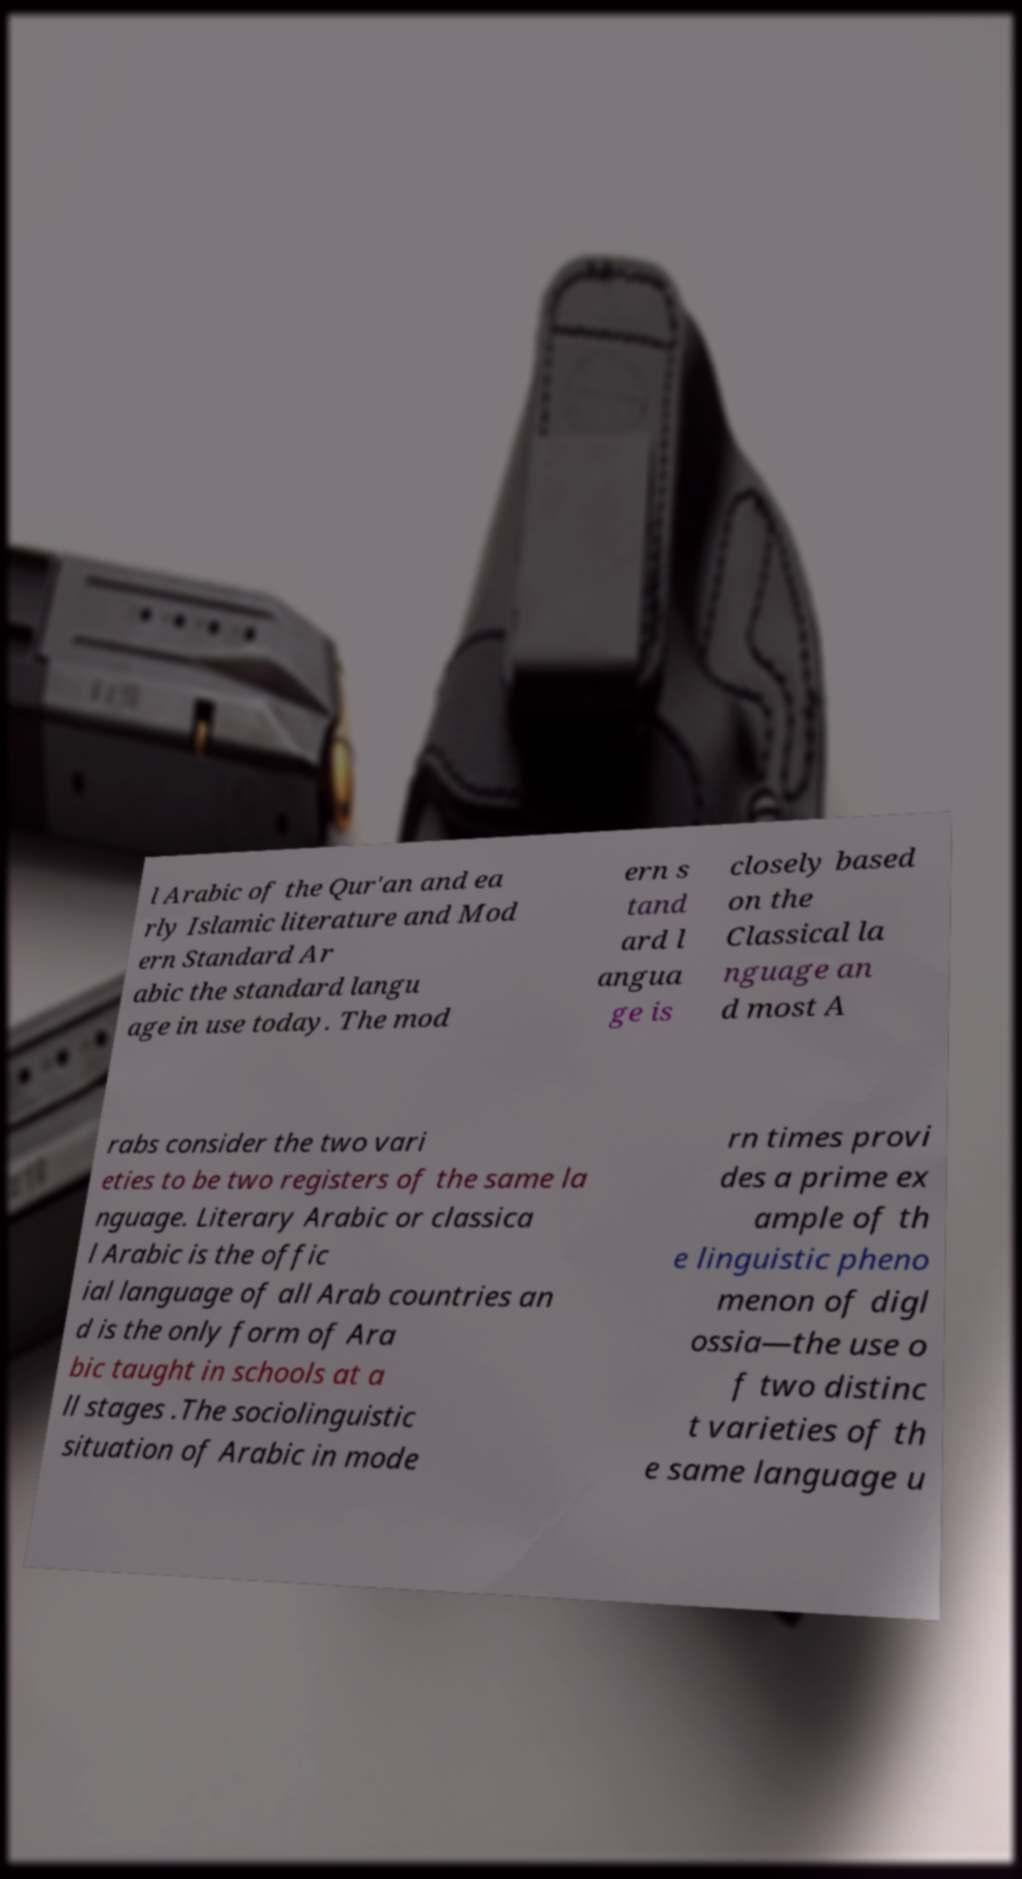Could you extract and type out the text from this image? l Arabic of the Qur'an and ea rly Islamic literature and Mod ern Standard Ar abic the standard langu age in use today. The mod ern s tand ard l angua ge is closely based on the Classical la nguage an d most A rabs consider the two vari eties to be two registers of the same la nguage. Literary Arabic or classica l Arabic is the offic ial language of all Arab countries an d is the only form of Ara bic taught in schools at a ll stages .The sociolinguistic situation of Arabic in mode rn times provi des a prime ex ample of th e linguistic pheno menon of digl ossia—the use o f two distinc t varieties of th e same language u 